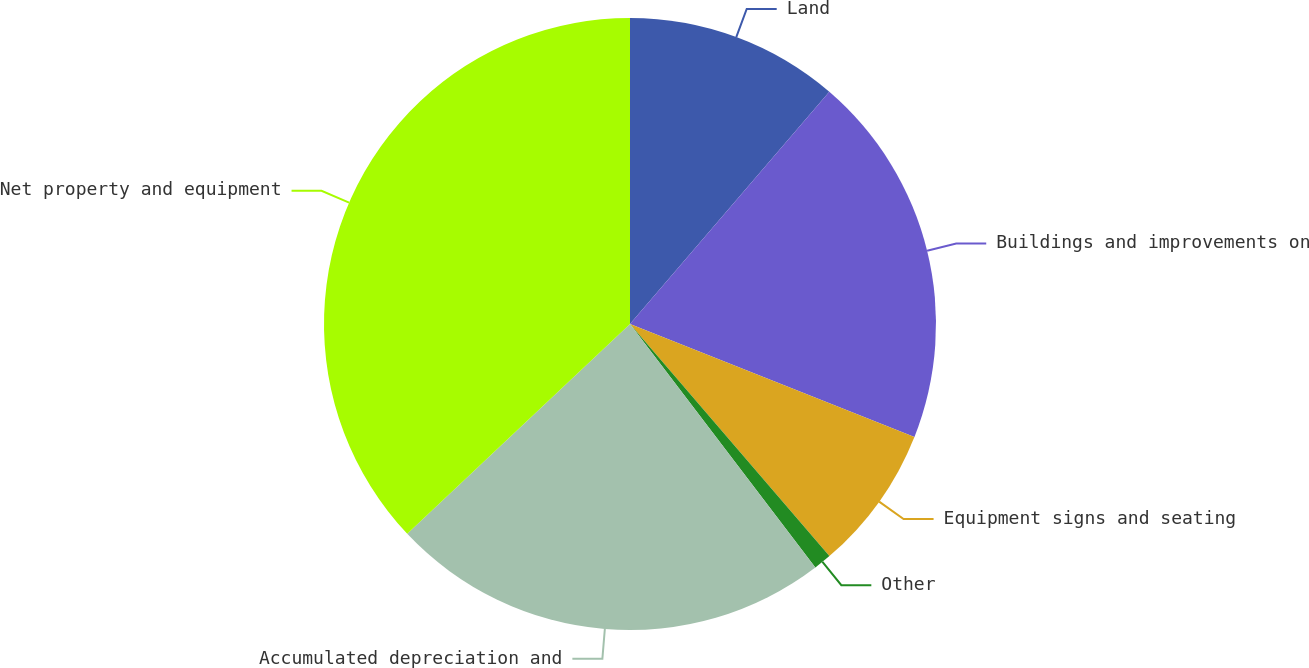Convert chart. <chart><loc_0><loc_0><loc_500><loc_500><pie_chart><fcel>Land<fcel>Buildings and improvements on<fcel>Equipment signs and seating<fcel>Other<fcel>Accumulated depreciation and<fcel>Net property and equipment<nl><fcel>11.29%<fcel>19.72%<fcel>7.69%<fcel>0.94%<fcel>23.33%<fcel>37.02%<nl></chart> 